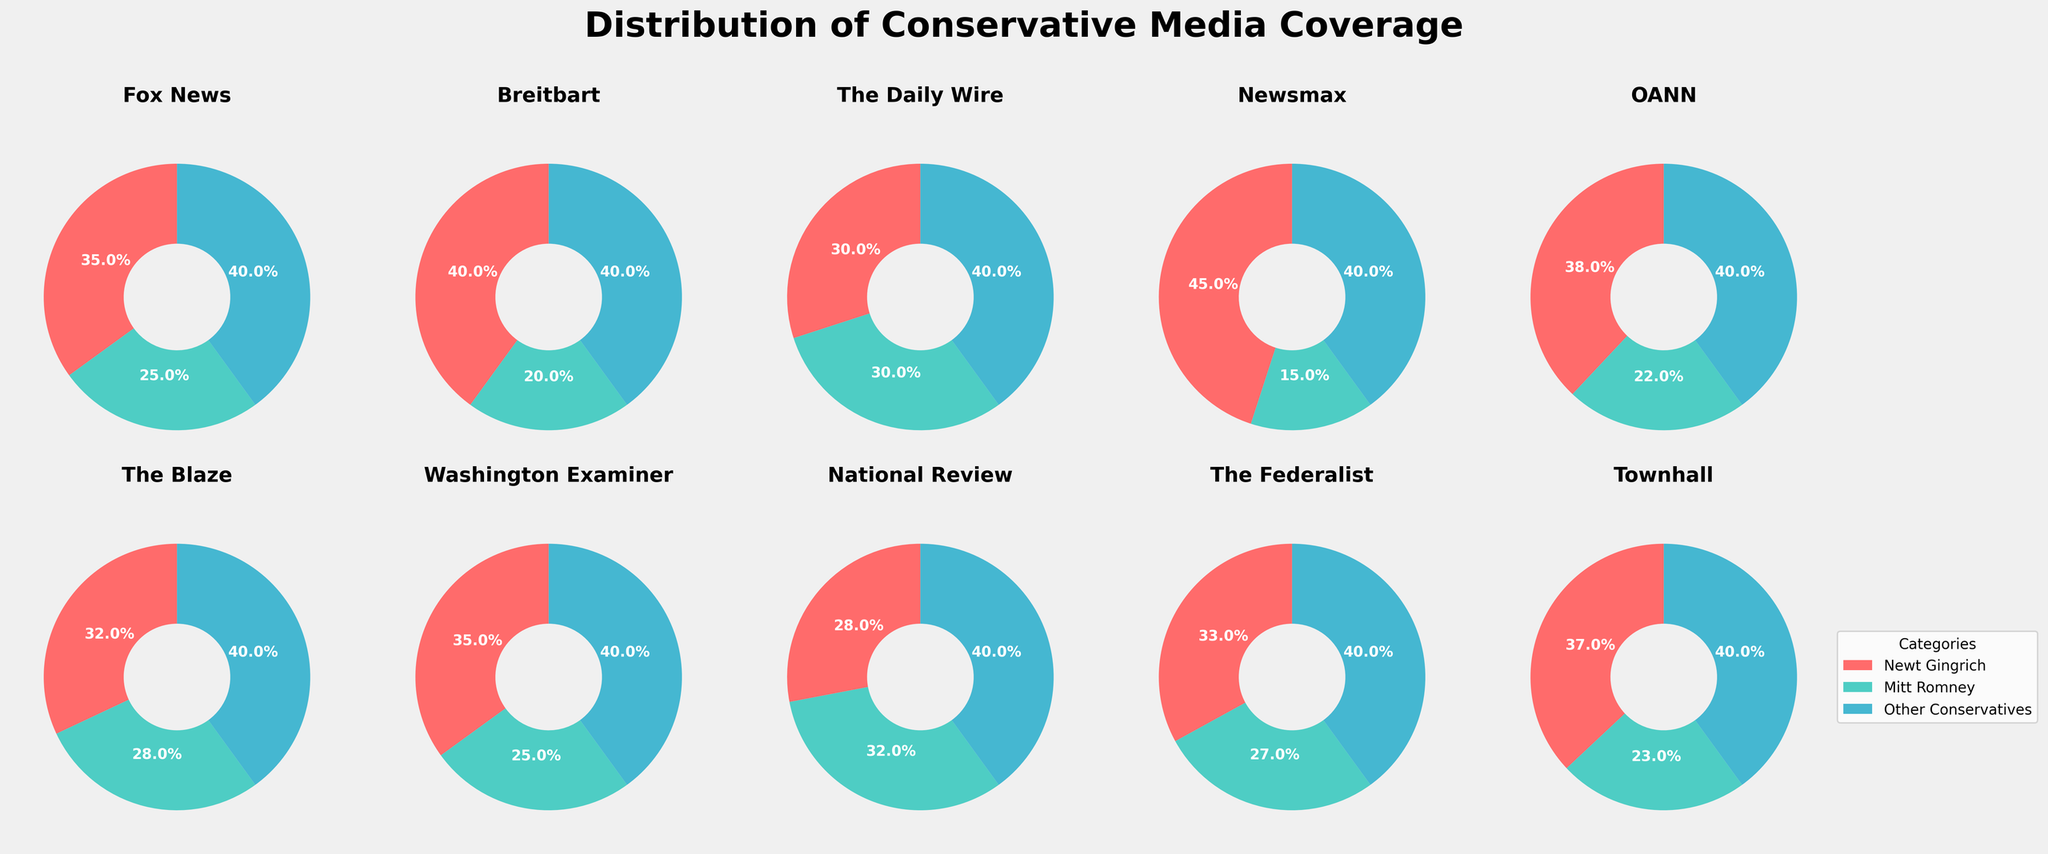Which media outlet shows the smallest percentage of coverage for Newt Gingrich? Look at the pie charts and identify the smallest segment for Newt Gingrich, which is in red. National Review shows the smallest percentage at 28%.
Answer: National Review Which media outlet devotes majority of its coverage to Newt Gingrich compared to Mitt Romney? Observe the pie charts and find the media outlets where the red segment (Newt Gingrich) is larger than the green segment (Mitt Romney). Newsmax has the highest percentage of coverage for Newt Gingrich at 45%.
Answer: Newsmax Is there any media outlet that gives equal coverage to both Newt Gingrich and Mitt Romney? Look at the pie charts and check if any outlets have equal-sized segments for Newt Gingrich (red) and Mitt Romney (green). The Daily Wire has equal coverage for both at 30% each.
Answer: The Daily Wire Which media outlet allocates the largest percentage to Mitt Romney? Identify the pie chart where the green segment (Mitt Romney) is the largest. National Review and The Daily Wire both show 32% coverage for Mitt Romney, which is the highest.
Answer: National Review and The Daily Wire Calculate the difference in coverage for Newt Gingrich between Newsmax and The Federalist. Newsmax shows 45% coverage for Newt Gingrich and The Federalist shows 33%. The difference is calculated as 45% - 33% = 12%.
Answer: 12% Which outlet shows the greatest contrast between Newt Gingrich and Mitt Romney coverage? Compare the pie charts, focusing on the difference between the red segment (Newt Gingrich) and green segment (Mitt Romney). Newsmax has a difference of 45% - 15% = 30%, which is the greatest.
Answer: Newsmax Which media outlet has the least coverage difference between Newt Gingrich and Mitt Romney, excluding the 'Other Conservatives' category? Compare the coverages (red and blue segments) and find the smallest difference. The Daily Wire has equal coverage, so the difference is 0%.
Answer: The Daily Wire On which outlets does Newt Gingrich receive more than 35% of coverage? Check each pie chart for outlets where Newt Gingrich's red segment exceeds 35%. Outlets include Fox News, Breitbart, Newsmax, OANN, and Townhall.
Answer: Fox News, Breitbart, Newsmax, OANN, Townhall Average the percentage of coverage for Newt Gingrich across all media outlets. Add up the percentages for Newt Gingrich from each outlet and then divide by the number of outlets: (35 + 40 + 30 + 45 + 38 + 32 + 35 + 28 + 33 + 37) / 10 = 35.3%.
Answer: 35.3% Which media outlet shows an equal coverage distribution between Newt Gingrich, Mitt Romney, and 'Other Conservatives'? Check the pie charts for any that visually show evenly divided segments into three equal parts. None of the outlets display an equal distribution.
Answer: None 